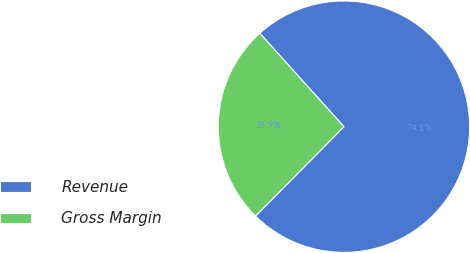Convert chart to OTSL. <chart><loc_0><loc_0><loc_500><loc_500><pie_chart><fcel>Revenue<fcel>Gross Margin<nl><fcel>74.09%<fcel>25.91%<nl></chart> 